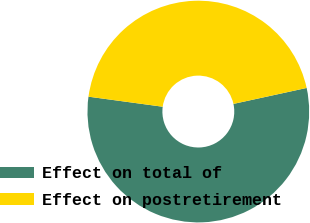<chart> <loc_0><loc_0><loc_500><loc_500><pie_chart><fcel>Effect on total of<fcel>Effect on postretirement<nl><fcel>55.56%<fcel>44.44%<nl></chart> 